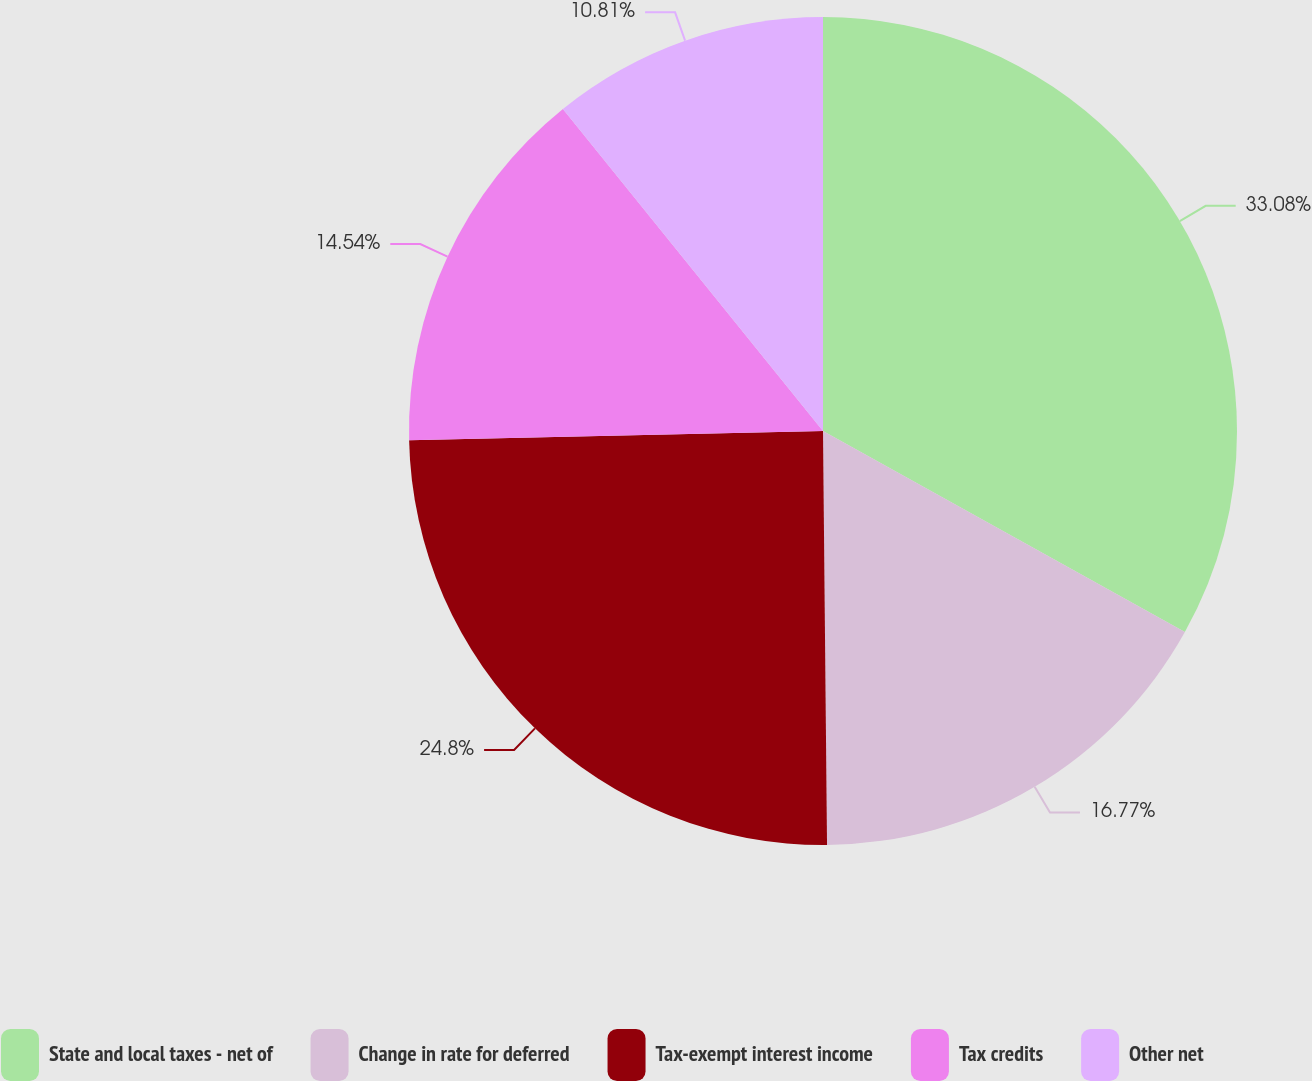<chart> <loc_0><loc_0><loc_500><loc_500><pie_chart><fcel>State and local taxes - net of<fcel>Change in rate for deferred<fcel>Tax-exempt interest income<fcel>Tax credits<fcel>Other net<nl><fcel>33.07%<fcel>16.77%<fcel>24.8%<fcel>14.54%<fcel>10.81%<nl></chart> 